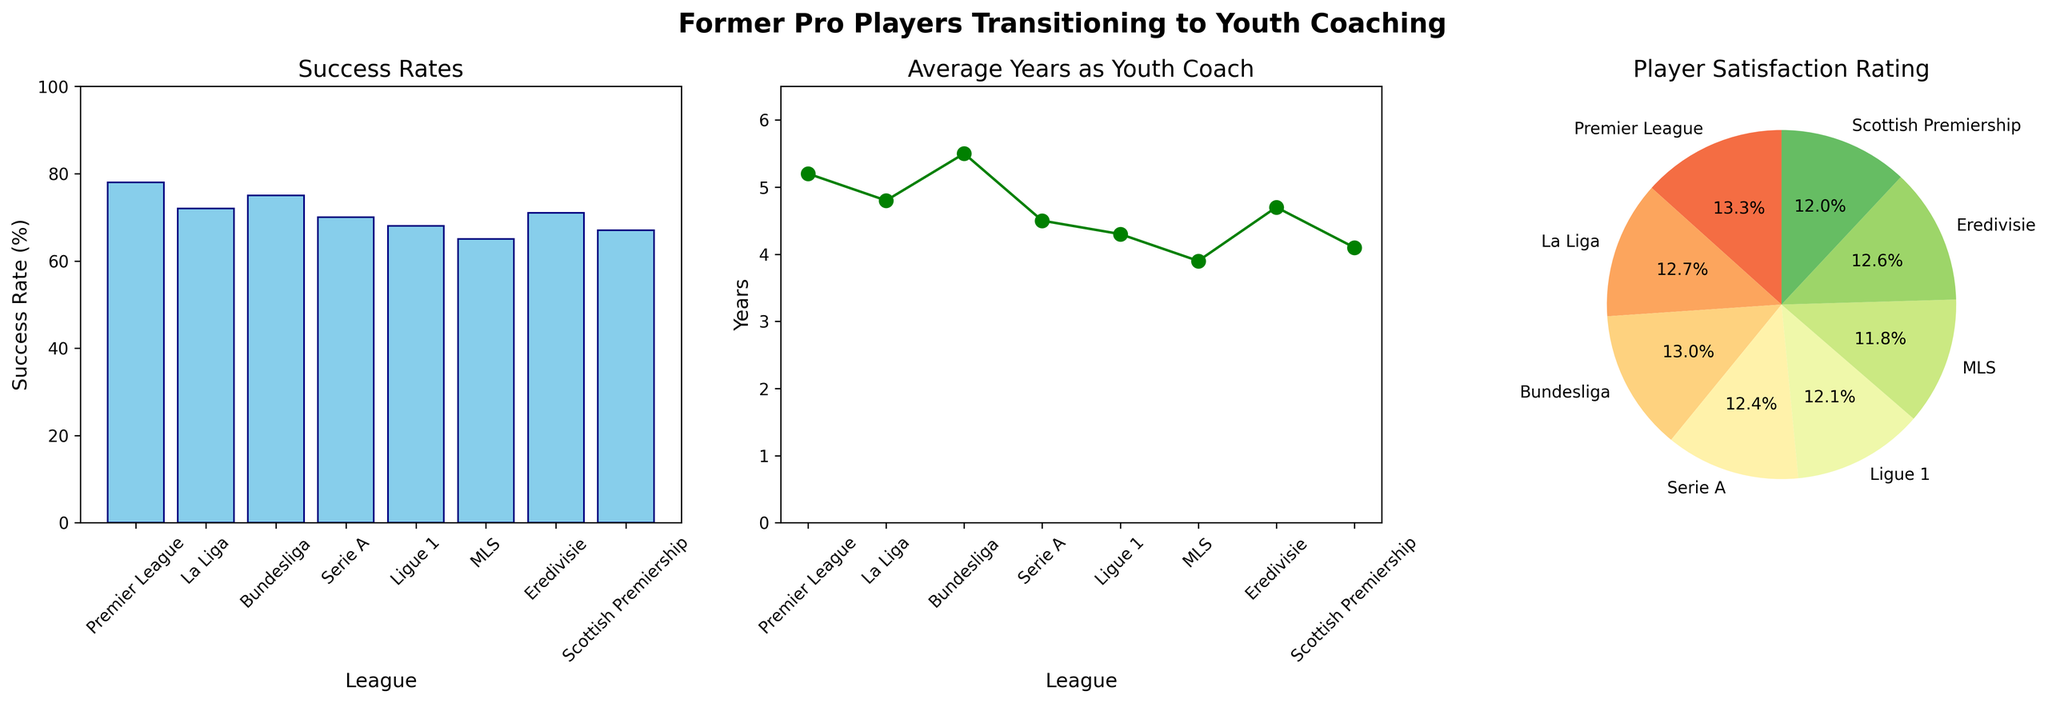What is the success rate of former pro players transitioning to youth coaches in the Premier League? Locate the bar for the Premier League in the "Success Rates" subplot. The height of the bar indicates the success rate.
Answer: 78% Which league has the lowest average years as a youth coach? Look at the line plot labeled "Average Years as Youth Coach." Identify the league with the lowest y-value.
Answer: MLS What is the difference in player satisfaction rating between La Liga and Bundesliga? Refer to the pie chart labeled "Player Satisfaction Rating." Find the sections for La Liga and Bundesliga and note their values. Subtract the smaller value from the larger one.
Answer: 8.5 - 8.3 = 0.2 Among the leagues shown, which has the second-highest success rate of former pro players becoming youth coaches? In the "Success Rates" subplot, rank the heights of the bars from highest to lowest. Identify the second-tallest bar.
Answer: Bundesliga Which league has a player satisfaction rating closest to 8.0? Refer to the pie chart labeled "Player Satisfaction Rating." Find the section whose value is closest to 8.0.
Answer: Serie A 